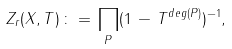<formula> <loc_0><loc_0><loc_500><loc_500>Z _ { r } ( X , T ) \, \colon = \, \prod _ { P } ( 1 \, - \, T ^ { d e g ( P ) } ) ^ { - 1 } ,</formula> 